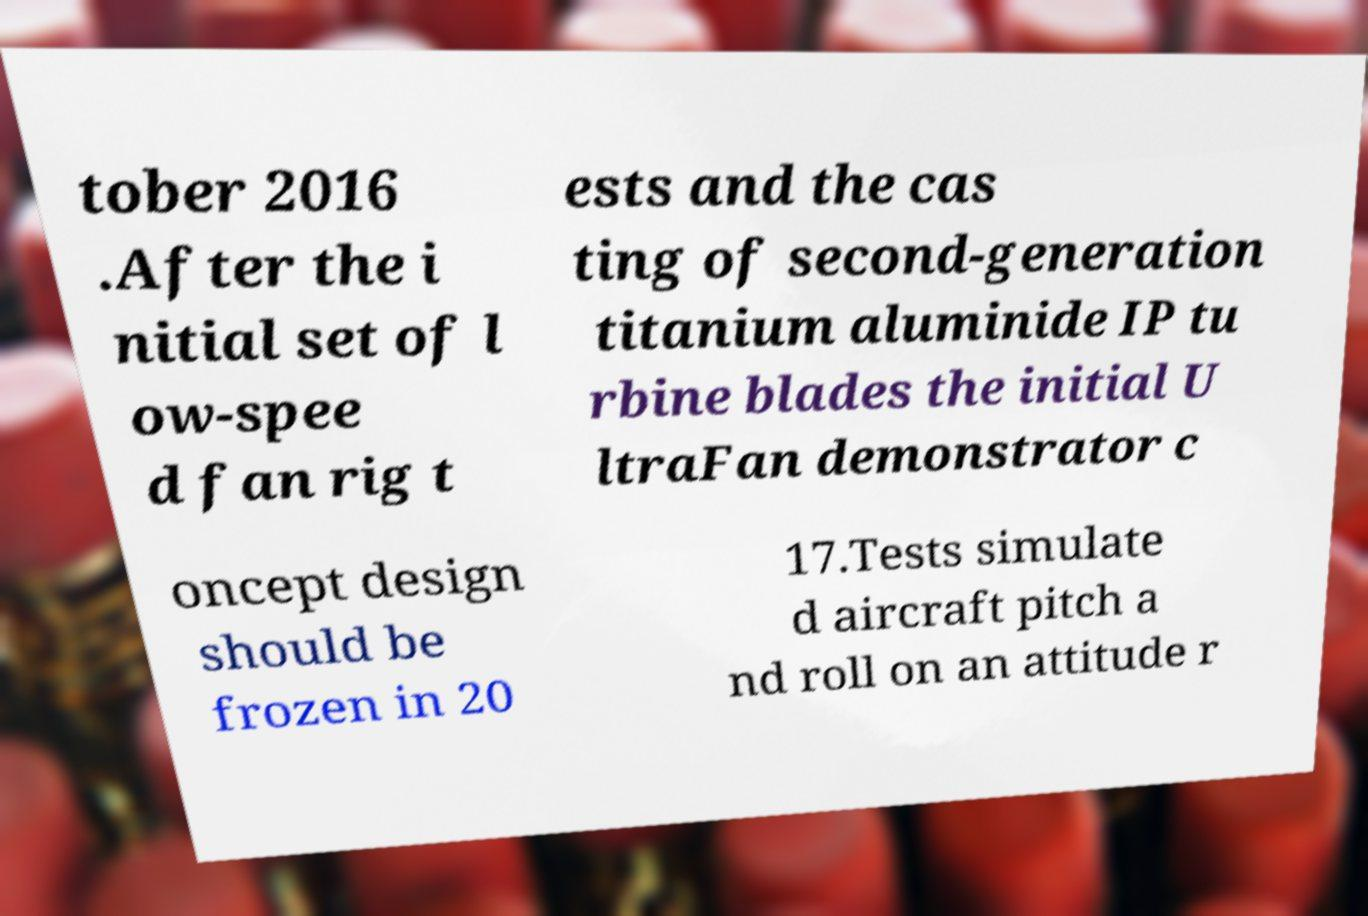There's text embedded in this image that I need extracted. Can you transcribe it verbatim? tober 2016 .After the i nitial set of l ow-spee d fan rig t ests and the cas ting of second-generation titanium aluminide IP tu rbine blades the initial U ltraFan demonstrator c oncept design should be frozen in 20 17.Tests simulate d aircraft pitch a nd roll on an attitude r 